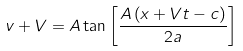<formula> <loc_0><loc_0><loc_500><loc_500>v + V = A \tan \left [ \frac { A \left ( x + V t - c \right ) } { 2 a } \right ]</formula> 